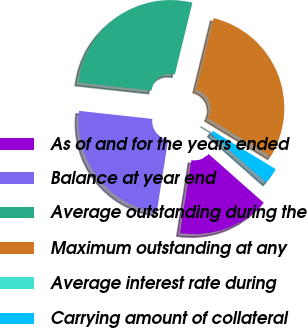Convert chart. <chart><loc_0><loc_0><loc_500><loc_500><pie_chart><fcel>As of and for the years ended<fcel>Balance at year end<fcel>Average outstanding during the<fcel>Maximum outstanding at any<fcel>Average interest rate during<fcel>Carrying amount of collateral<nl><fcel>15.97%<fcel>24.25%<fcel>27.07%<fcel>29.89%<fcel>0.0%<fcel>2.83%<nl></chart> 